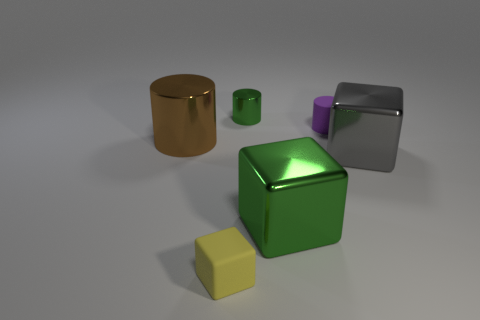What number of objects are yellow matte cylinders or small things to the left of the tiny green metallic cylinder?
Your response must be concise. 1. Are there any big cubes made of the same material as the big brown cylinder?
Make the answer very short. Yes. There is a cylinder that is the same size as the gray metallic cube; what is it made of?
Give a very brief answer. Metal. What is the material of the big thing left of the yellow matte cube in front of the gray cube?
Make the answer very short. Metal. Do the matte thing to the left of the matte cylinder and the gray shiny object have the same shape?
Offer a very short reply. Yes. The cylinder that is made of the same material as the yellow block is what color?
Your answer should be very brief. Purple. What is the big thing to the left of the big green metallic object made of?
Give a very brief answer. Metal. There is a purple rubber thing; is its shape the same as the green thing right of the tiny green object?
Provide a succinct answer. No. What material is the small object that is to the left of the green metallic cube and behind the yellow object?
Ensure brevity in your answer.  Metal. There is a metallic cylinder that is the same size as the yellow rubber object; what is its color?
Your response must be concise. Green. 